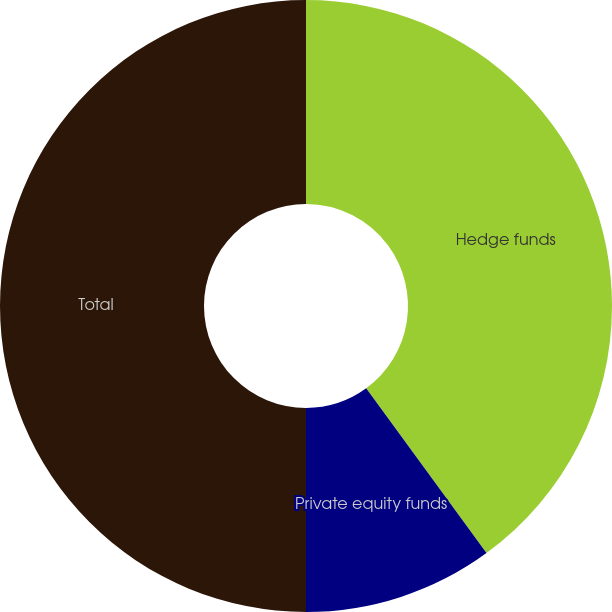Convert chart. <chart><loc_0><loc_0><loc_500><loc_500><pie_chart><fcel>Hedge funds<fcel>Private equity funds<fcel>Total<nl><fcel>39.96%<fcel>10.04%<fcel>50.0%<nl></chart> 